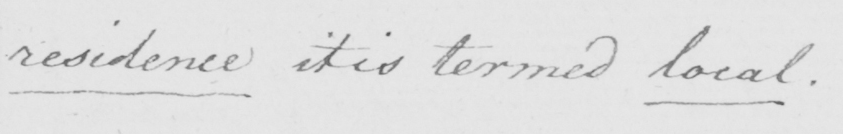Transcribe the text shown in this historical manuscript line. residence it is termed local . 